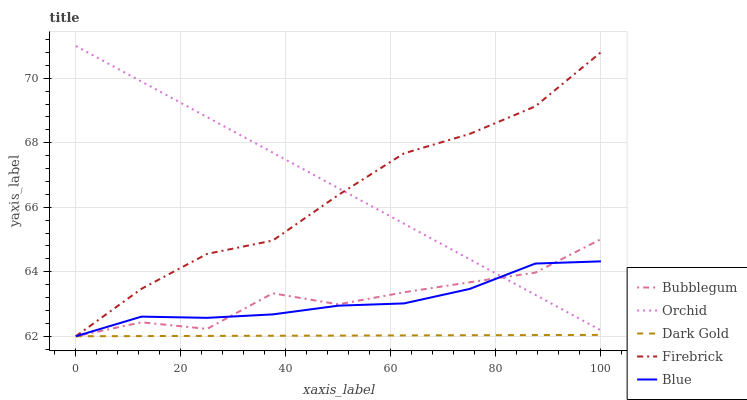Does Dark Gold have the minimum area under the curve?
Answer yes or no. Yes. Does Orchid have the maximum area under the curve?
Answer yes or no. Yes. Does Firebrick have the minimum area under the curve?
Answer yes or no. No. Does Firebrick have the maximum area under the curve?
Answer yes or no. No. Is Orchid the smoothest?
Answer yes or no. Yes. Is Bubblegum the roughest?
Answer yes or no. Yes. Is Firebrick the smoothest?
Answer yes or no. No. Is Firebrick the roughest?
Answer yes or no. No. Does Blue have the lowest value?
Answer yes or no. Yes. Does Orchid have the lowest value?
Answer yes or no. No. Does Orchid have the highest value?
Answer yes or no. Yes. Does Firebrick have the highest value?
Answer yes or no. No. Is Dark Gold less than Orchid?
Answer yes or no. Yes. Is Orchid greater than Dark Gold?
Answer yes or no. Yes. Does Orchid intersect Bubblegum?
Answer yes or no. Yes. Is Orchid less than Bubblegum?
Answer yes or no. No. Is Orchid greater than Bubblegum?
Answer yes or no. No. Does Dark Gold intersect Orchid?
Answer yes or no. No. 